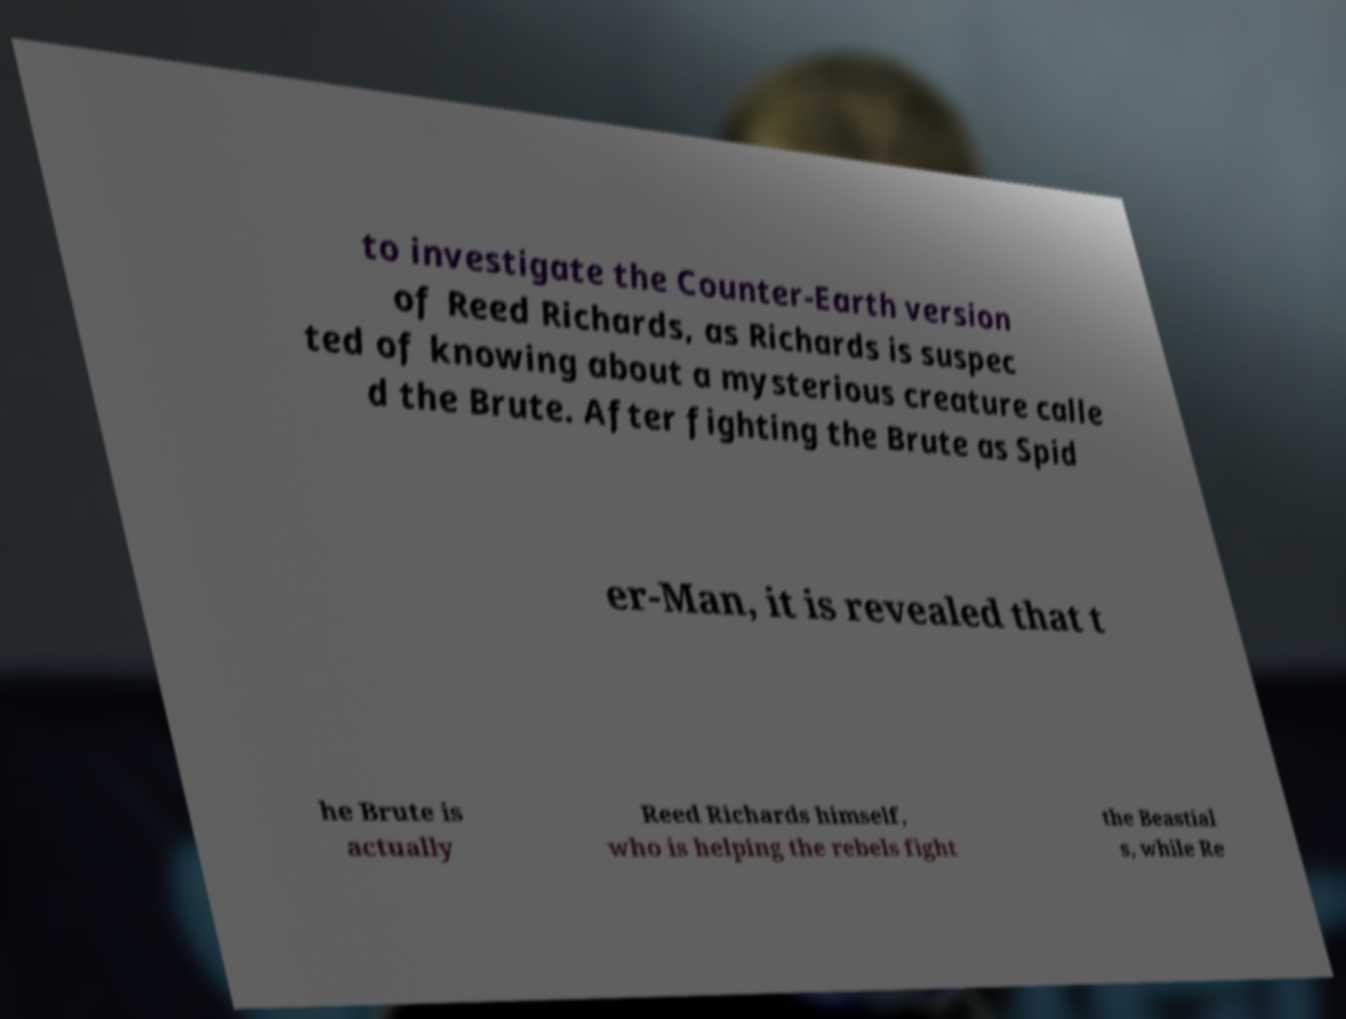Can you read and provide the text displayed in the image?This photo seems to have some interesting text. Can you extract and type it out for me? to investigate the Counter-Earth version of Reed Richards, as Richards is suspec ted of knowing about a mysterious creature calle d the Brute. After fighting the Brute as Spid er-Man, it is revealed that t he Brute is actually Reed Richards himself, who is helping the rebels fight the Beastial s, while Re 